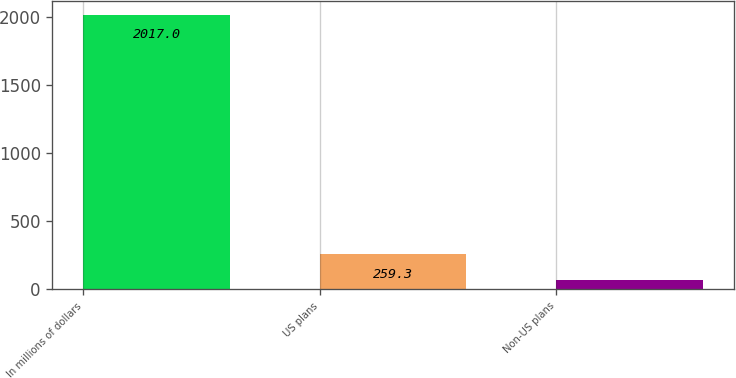Convert chart. <chart><loc_0><loc_0><loc_500><loc_500><bar_chart><fcel>In millions of dollars<fcel>US plans<fcel>Non-US plans<nl><fcel>2017<fcel>259.3<fcel>64<nl></chart> 